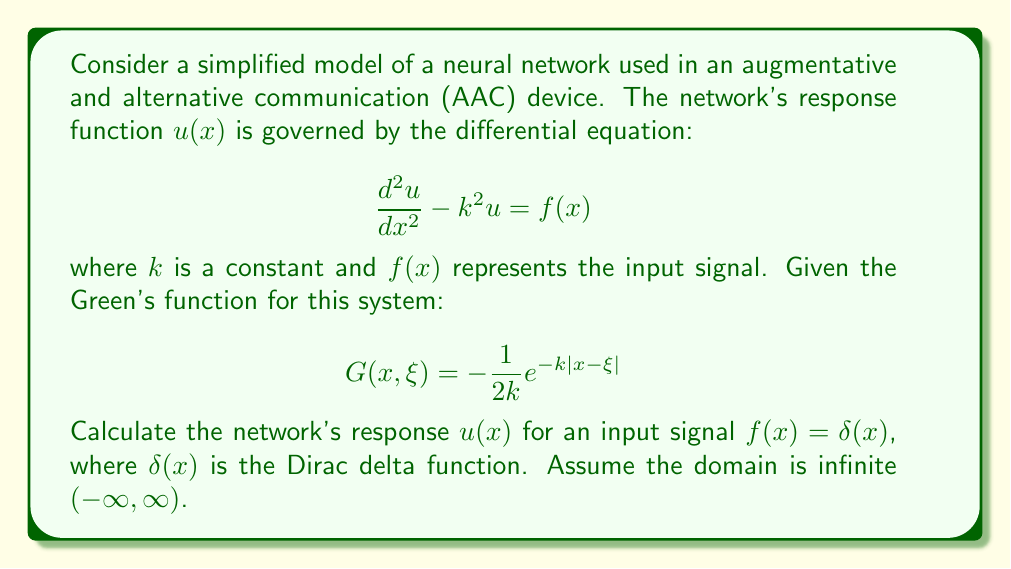Solve this math problem. To solve this problem, we'll use the Green's function method:

1) The general solution using Green's function is given by:

   $$u(x) = \int_{-\infty}^{\infty} G(x,\xi)f(\xi)d\xi$$

2) Substituting the given Green's function and input signal:

   $$u(x) = \int_{-\infty}^{\infty} \left(-\frac{1}{2k}e^{-k|x-\xi|}\right)\delta(\xi)d\xi$$

3) The Dirac delta function has the sifting property:

   $$\int_{-\infty}^{\infty} f(\xi)\delta(\xi)d\xi = f(0)$$

4) Applying this property to our integral:

   $$u(x) = -\frac{1}{2k}e^{-k|x-0|}$$

5) Simplify:

   $$u(x) = -\frac{1}{2k}e^{-k|x|}$$

This result represents the impulse response of the neural network model, which could be used to analyze and optimize the AAC device's performance.
Answer: $$u(x) = -\frac{1}{2k}e^{-k|x|}$$ 